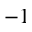<formula> <loc_0><loc_0><loc_500><loc_500>- 1</formula> 